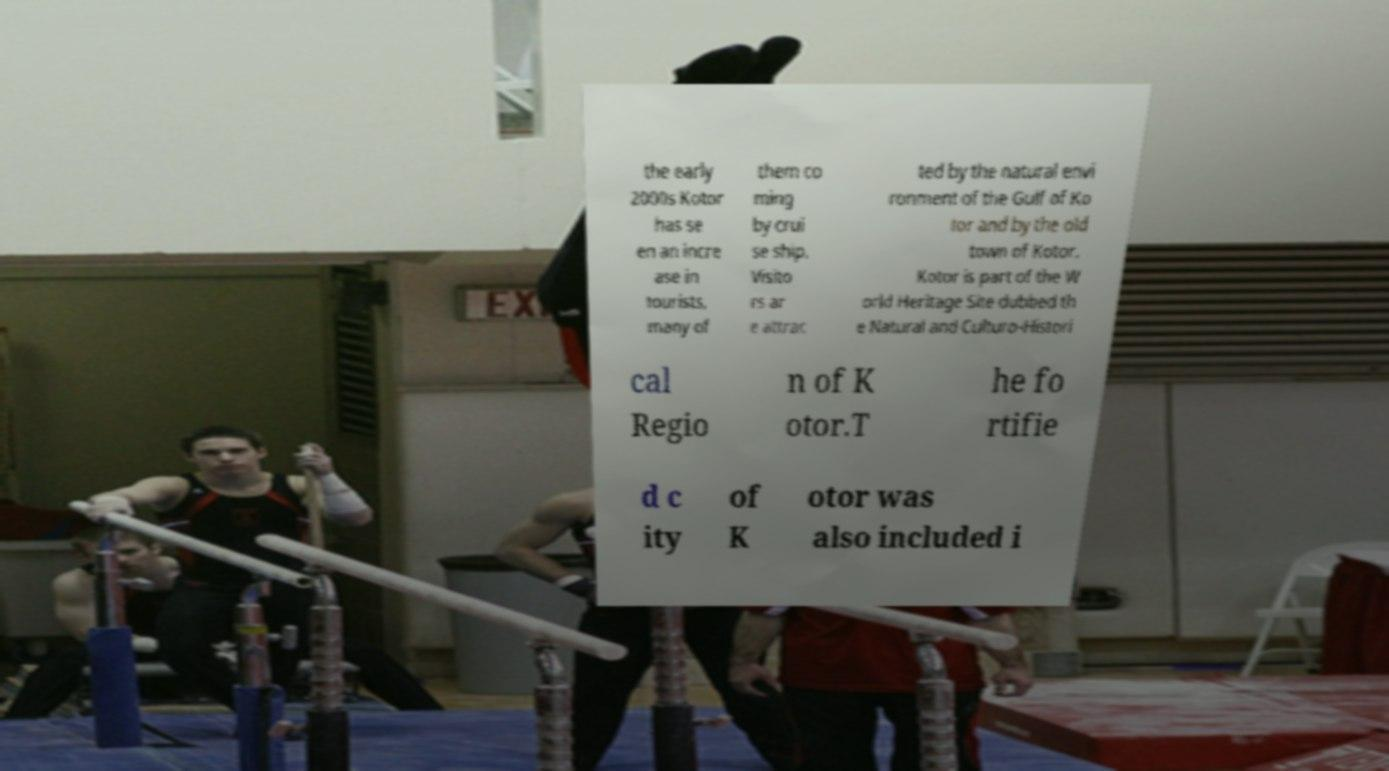What messages or text are displayed in this image? I need them in a readable, typed format. the early 2000s Kotor has se en an incre ase in tourists, many of them co ming by crui se ship. Visito rs ar e attrac ted by the natural envi ronment of the Gulf of Ko tor and by the old town of Kotor. Kotor is part of the W orld Heritage Site dubbed th e Natural and Culturo-Histori cal Regio n of K otor.T he fo rtifie d c ity of K otor was also included i 